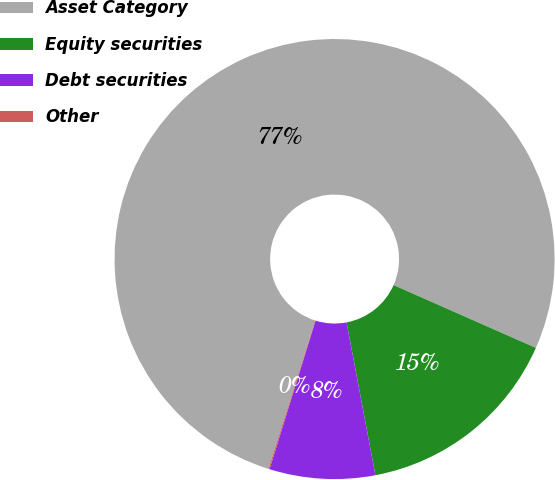<chart> <loc_0><loc_0><loc_500><loc_500><pie_chart><fcel>Asset Category<fcel>Equity securities<fcel>Debt securities<fcel>Other<nl><fcel>76.76%<fcel>15.41%<fcel>7.75%<fcel>0.08%<nl></chart> 